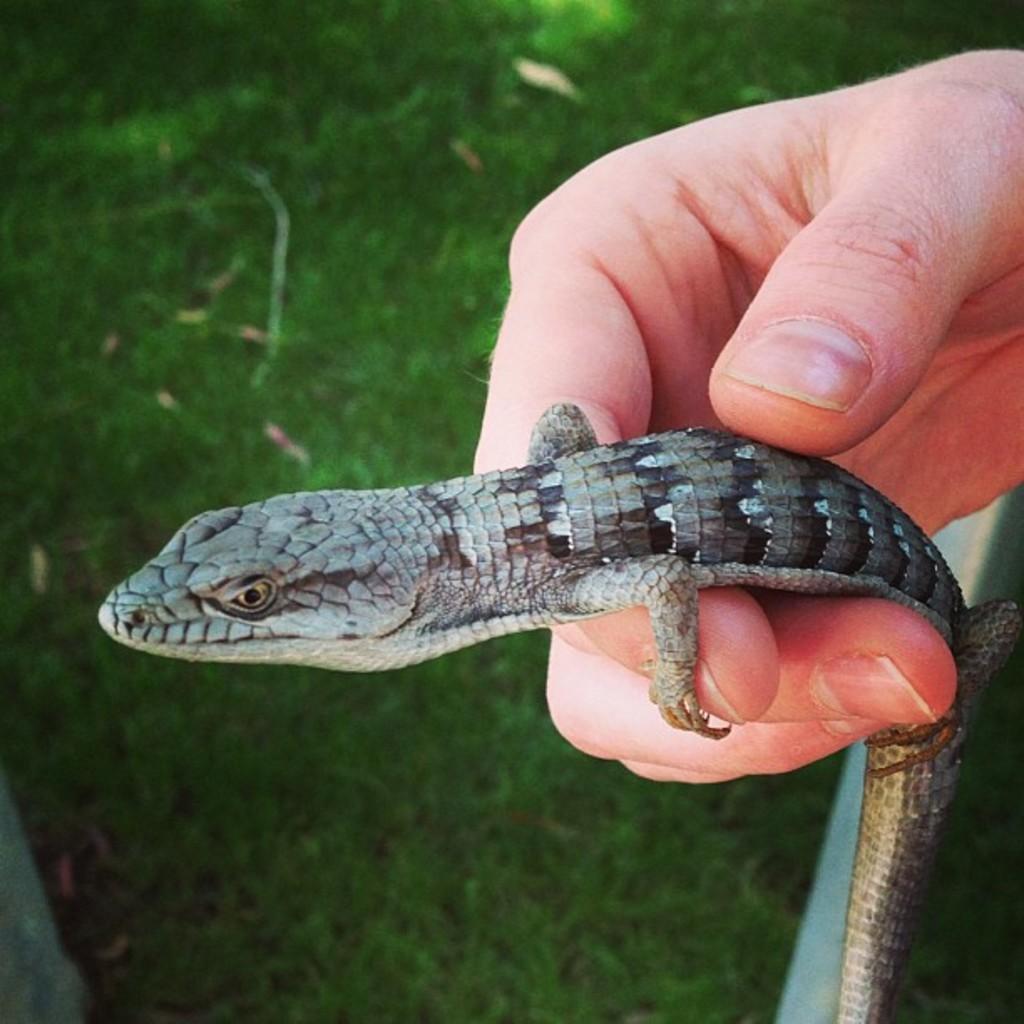In one or two sentences, can you explain what this image depicts? In this image we can see a person's hand who is holding alligator. 